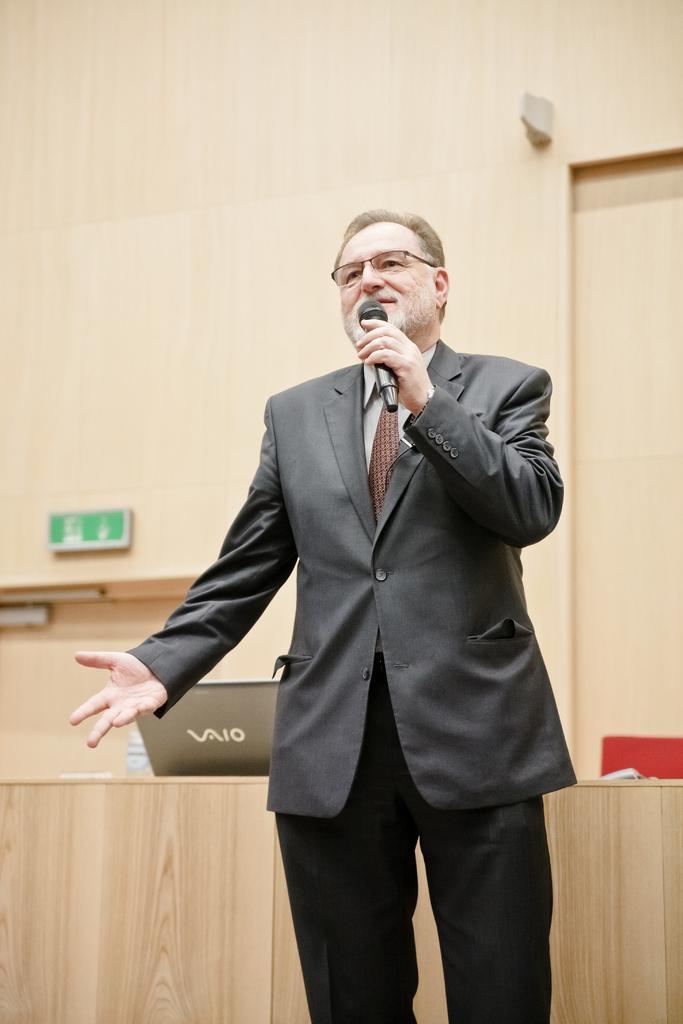How would you summarize this image in a sentence or two? In this image we can see a man standing on the floor and holding a mic in his hand. In the background we can see a table and on the table there are laptop, papers and a disposal bottle. 